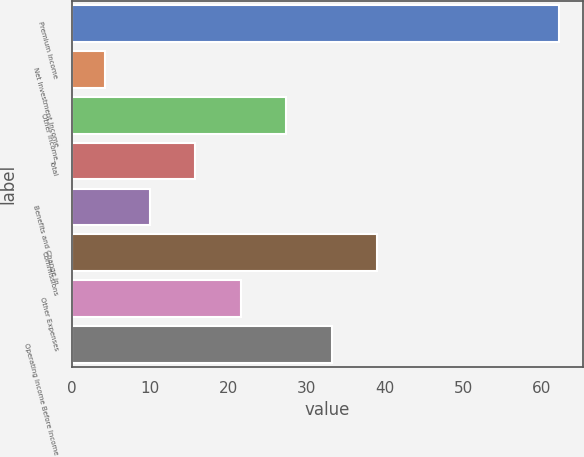<chart> <loc_0><loc_0><loc_500><loc_500><bar_chart><fcel>Premium Income<fcel>Net Investment Income<fcel>Other Income<fcel>Total<fcel>Benefits and Change in<fcel>Commissions<fcel>Other Expenses<fcel>Operating Income Before Income<nl><fcel>62.2<fcel>4.2<fcel>27.4<fcel>15.8<fcel>10<fcel>39<fcel>21.6<fcel>33.2<nl></chart> 